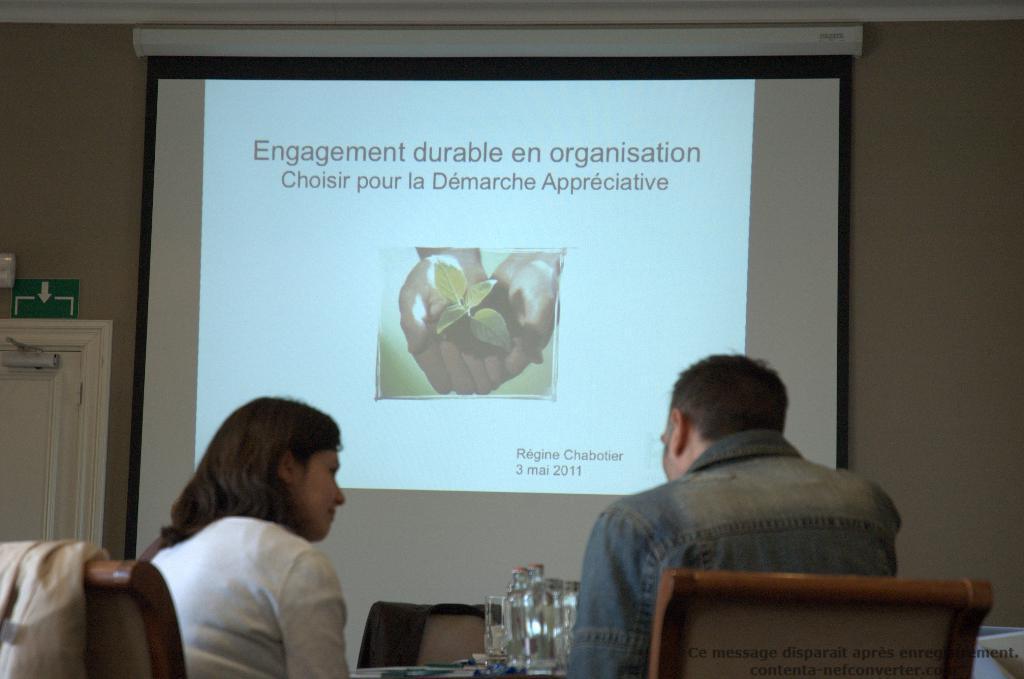Can you describe this image briefly? In this picture we can see a woman and a man sitting on the chairs. This is the table. On the table there are some glasses. On the background we can see a screen and this is the wall. And there is a door. 